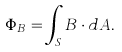Convert formula to latex. <formula><loc_0><loc_0><loc_500><loc_500>\Phi _ { B } = \int _ { S } B \cdot d A . \,</formula> 